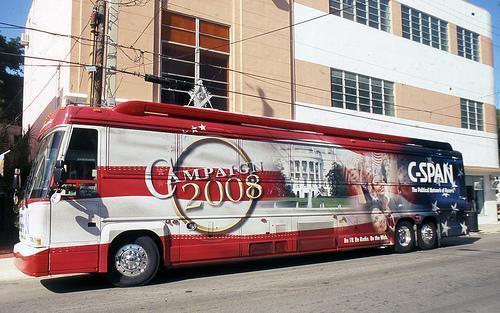How many bicycles are in the road?
Give a very brief answer. 0. 